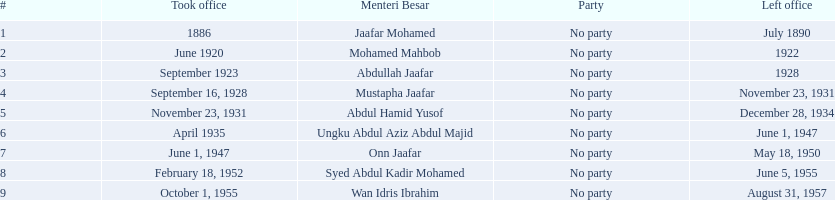Which menteri besars took office in the 1920's? Mohamed Mahbob, Abdullah Jaafar, Mustapha Jaafar. Of those men, who was only in office for 2 years? Mohamed Mahbob. 